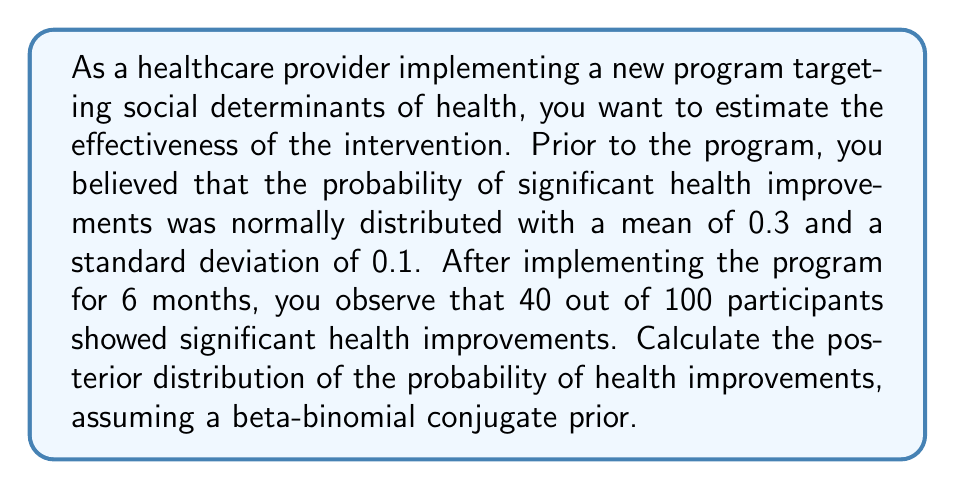Show me your answer to this math problem. To solve this problem, we'll use Bayesian inference with a beta-binomial conjugate prior. The steps are as follows:

1. Convert the prior normal distribution to an approximate beta distribution:
   The normal distribution has mean $\mu = 0.3$ and standard deviation $\sigma = 0.1$.
   We can approximate this with a beta distribution using the method of moments:

   $$\alpha = \mu \left(\frac{\mu(1-\mu)}{\sigma^2} - 1\right) = 0.3 \left(\frac{0.3(1-0.3)}{0.1^2} - 1\right) \approx 7.2$$
   $$\beta = (1-\mu) \left(\frac{\mu(1-\mu)}{\sigma^2} - 1\right) = 0.7 \left(\frac{0.3(1-0.3)}{0.1^2} - 1\right) \approx 16.8$$

2. Update the prior with the observed data:
   Prior: $Beta(\alpha, \beta) = Beta(7.2, 16.8)$
   Data: 40 successes out of 100 trials
   
   Posterior: $Beta(\alpha + successes, \beta + failures)$
             $= Beta(7.2 + 40, 16.8 + 60)$
             $= Beta(47.2, 76.8)$

3. Calculate the posterior mean and standard deviation:
   Mean: $\mu_{posterior} = \frac{\alpha_{posterior}}{\alpha_{posterior} + \beta_{posterior}} = \frac{47.2}{47.2 + 76.8} \approx 0.3806$
   
   Variance: $\sigma^2_{posterior} = \frac{\alpha_{posterior}\beta_{posterior}}{(\alpha_{posterior} + \beta_{posterior})^2(\alpha_{posterior} + \beta_{posterior} + 1)}$
   
   $\sigma_{posterior} = \sqrt{\frac{47.2 \times 76.8}{(47.2 + 76.8)^2(47.2 + 76.8 + 1)}} \approx 0.0436$

Therefore, the posterior distribution of the probability of health improvements is approximately normal with mean 0.3806 and standard deviation 0.0436.
Answer: The posterior distribution of the probability of health improvements is approximately normal with mean $\mu_{posterior} \approx 0.3806$ and standard deviation $\sigma_{posterior} \approx 0.0436$. 